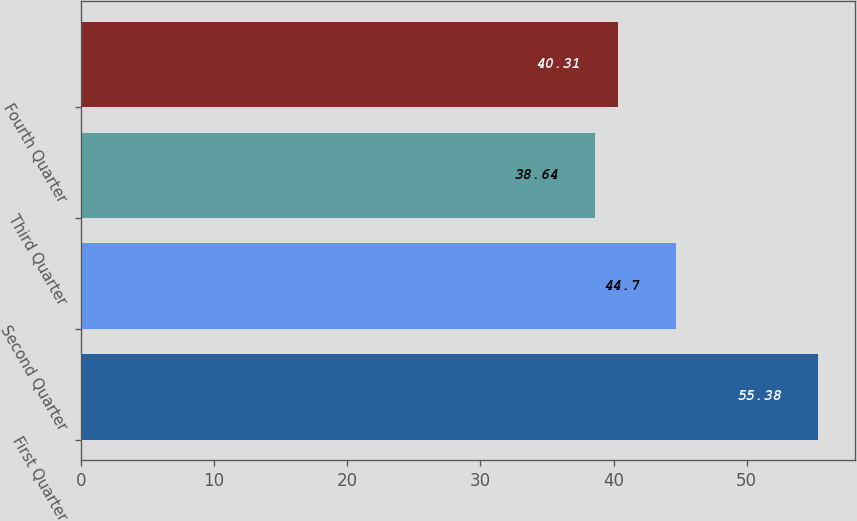Convert chart to OTSL. <chart><loc_0><loc_0><loc_500><loc_500><bar_chart><fcel>First Quarter<fcel>Second Quarter<fcel>Third Quarter<fcel>Fourth Quarter<nl><fcel>55.38<fcel>44.7<fcel>38.64<fcel>40.31<nl></chart> 